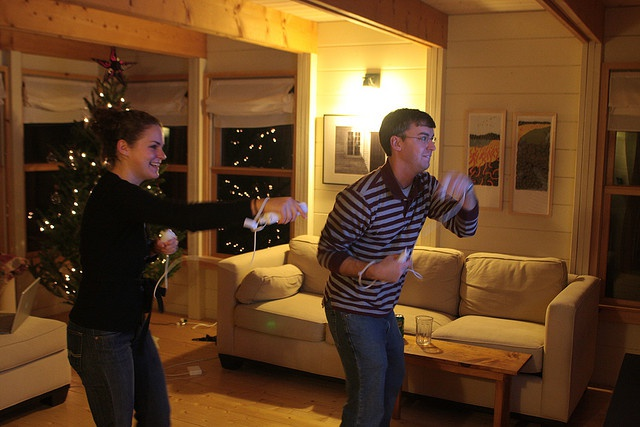Describe the objects in this image and their specific colors. I can see couch in maroon, black, and olive tones, people in maroon, black, and gray tones, people in maroon, black, and brown tones, couch in maroon, brown, and black tones, and laptop in maroon, black, and brown tones in this image. 